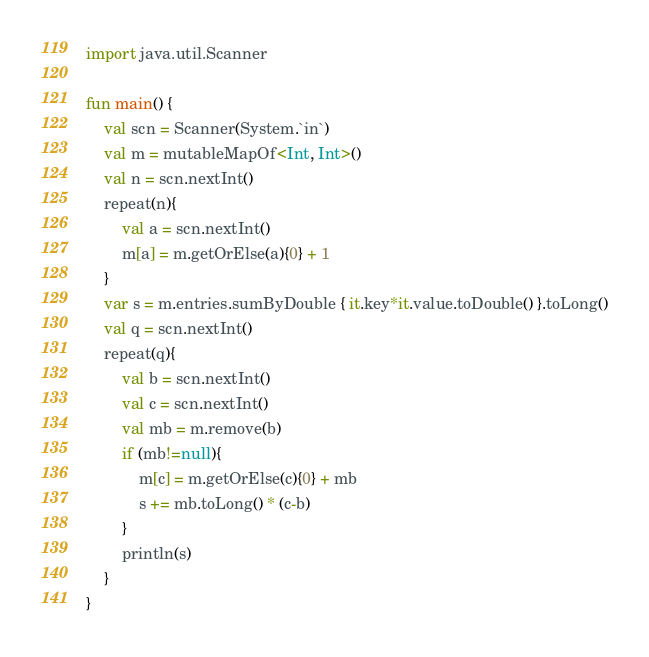Convert code to text. <code><loc_0><loc_0><loc_500><loc_500><_Kotlin_>import java.util.Scanner

fun main() {
	val scn = Scanner(System.`in`)
	val m = mutableMapOf<Int, Int>()
	val n = scn.nextInt()
	repeat(n){
		val a = scn.nextInt()
		m[a] = m.getOrElse(a){0} + 1
	}
	var s = m.entries.sumByDouble { it.key*it.value.toDouble() }.toLong()
	val q = scn.nextInt()
	repeat(q){
		val b = scn.nextInt()
		val c = scn.nextInt()
		val mb = m.remove(b)
		if (mb!=null){
			m[c] = m.getOrElse(c){0} + mb
			s += mb.toLong() * (c-b)
		}
		println(s)
	}
}
</code> 